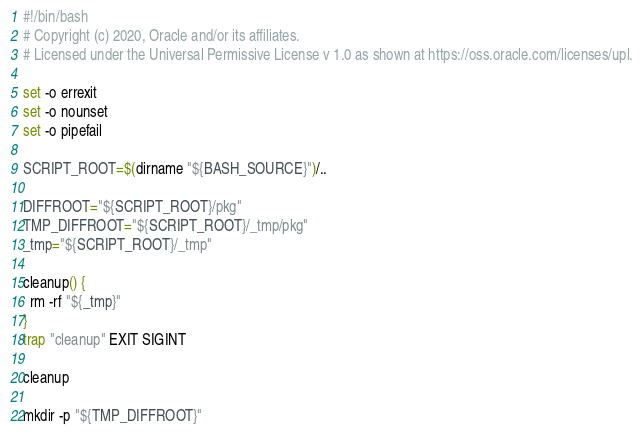Convert code to text. <code><loc_0><loc_0><loc_500><loc_500><_Bash_>#!/bin/bash
# Copyright (c) 2020, Oracle and/or its affiliates.
# Licensed under the Universal Permissive License v 1.0 as shown at https://oss.oracle.com/licenses/upl.

set -o errexit
set -o nounset
set -o pipefail

SCRIPT_ROOT=$(dirname "${BASH_SOURCE}")/..

DIFFROOT="${SCRIPT_ROOT}/pkg"
TMP_DIFFROOT="${SCRIPT_ROOT}/_tmp/pkg"
_tmp="${SCRIPT_ROOT}/_tmp"

cleanup() {
  rm -rf "${_tmp}"
}
trap "cleanup" EXIT SIGINT

cleanup

mkdir -p "${TMP_DIFFROOT}"</code> 